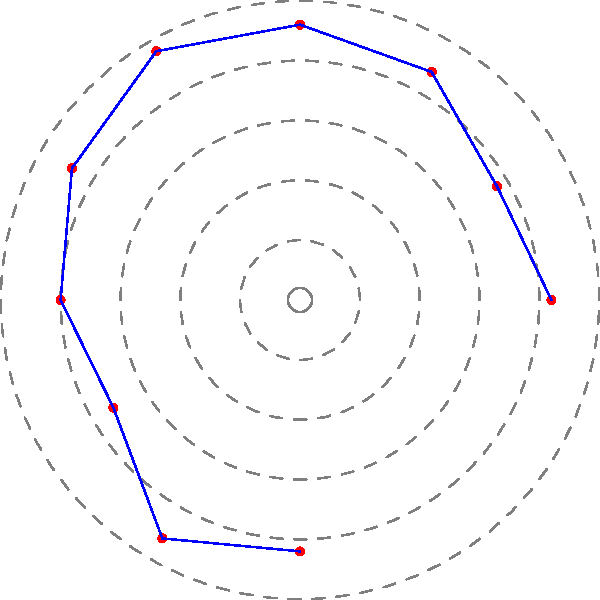The polar coordinate plot shows Hartlepool United's league positions over the past decade. Each concentric circle represents a step of 5 in league position, with the center being position 0 and the outermost circle being position 25. The angles represent the seasons, starting from 0° for the earliest season and increasing by 30° for each subsequent season. What was Hartlepool United's best league position during this period? To find Hartlepool United's best league position, we need to analyze the plot step-by-step:

1. Understand the plot:
   - Each point represents a season's league position.
   - The closer a point is to the center, the better the position (lower number).
   - The angles represent seasons, starting from 0° and increasing by 30° each season.

2. Identify all points:
   - 0°: approximately position 21
   - 30°: approximately position 19
   - 60°: approximately position 22
   - 90°: approximately position 23
   - 120°: approximately position 24
   - 150°: approximately position 22
   - 180°: approximately position 20
   - 210°: approximately position 18
   - 240°: approximately position 23
   - 270°: approximately position 21

3. Find the lowest number:
   The lowest number (closest to the center) is 18, which occurs at 210°.

Therefore, Hartlepool United's best league position during this period was 18th.
Answer: 18th 